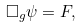<formula> <loc_0><loc_0><loc_500><loc_500>\Box _ { g } \psi = F ,</formula> 